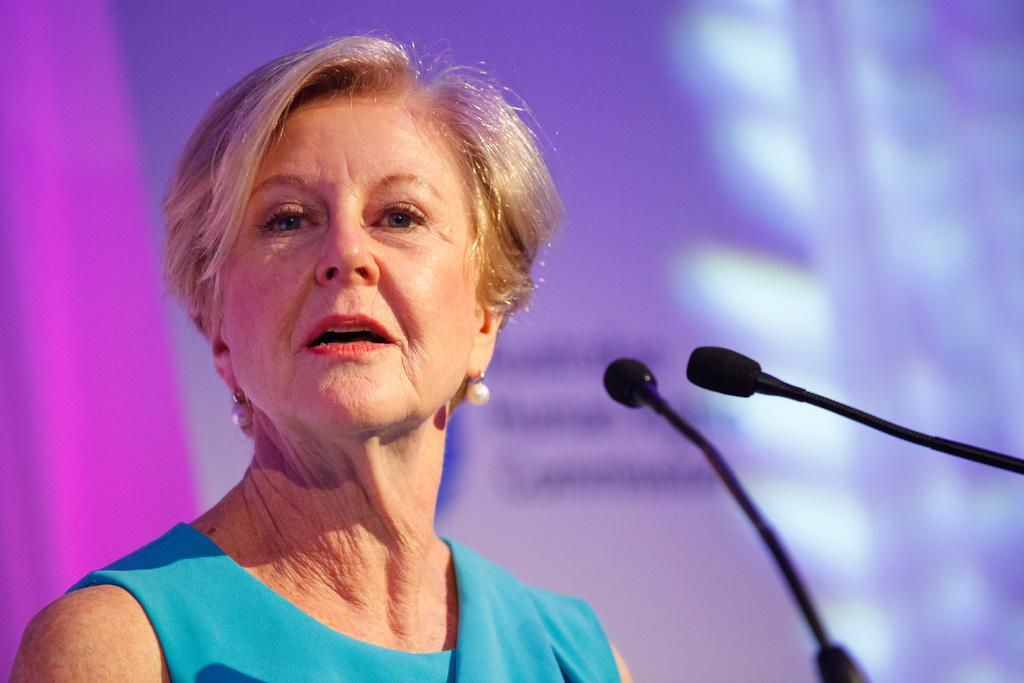Who is present in the image? There is a woman in the image. What is the woman wearing? The woman is wearing a blue dress. What can be seen on the right side of the image? There are mics on the right side of the image. Where is the hose located in the image? There is no hose present in the image. What type of airport is visible in the image? There is no airport present in the image. 